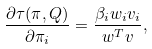<formula> <loc_0><loc_0><loc_500><loc_500>\frac { \partial \tau ( \pi , Q ) } { \partial \pi _ { i } } = \frac { \beta _ { i } w _ { i } v _ { i } } { { w } ^ { T } { v } } ,</formula> 